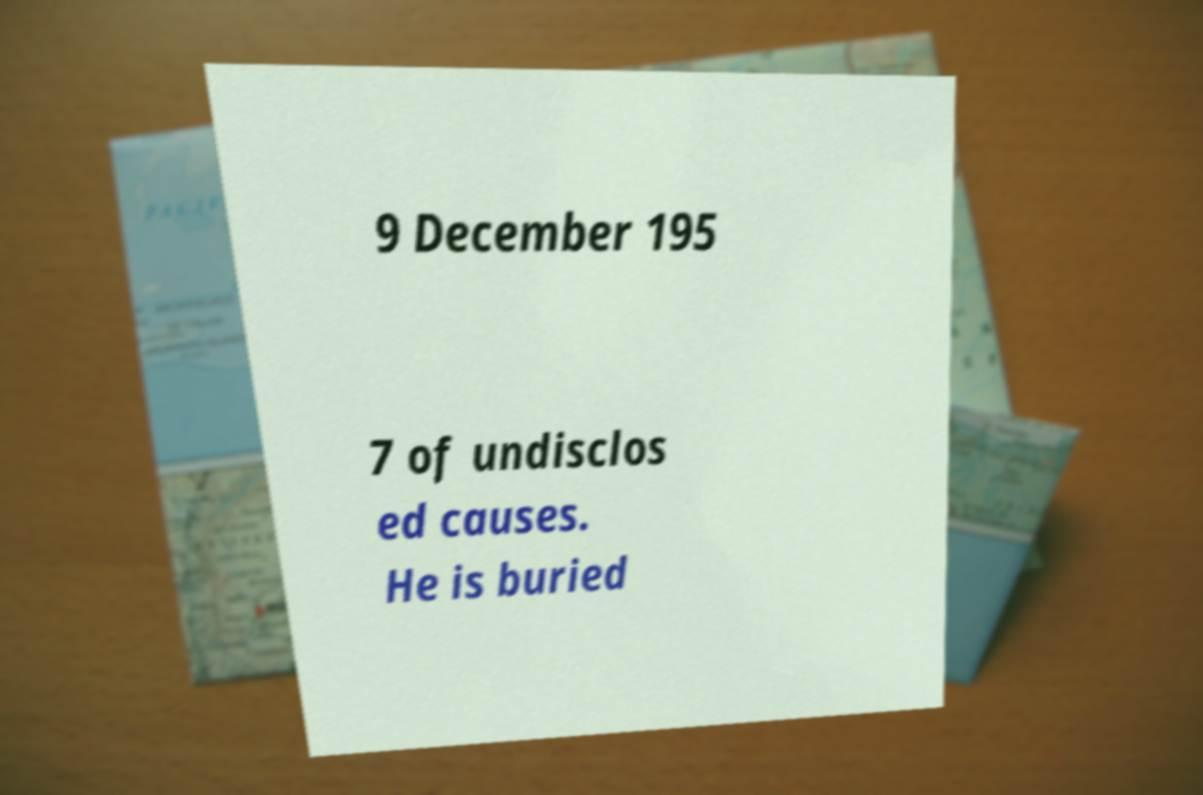For documentation purposes, I need the text within this image transcribed. Could you provide that? 9 December 195 7 of undisclos ed causes. He is buried 